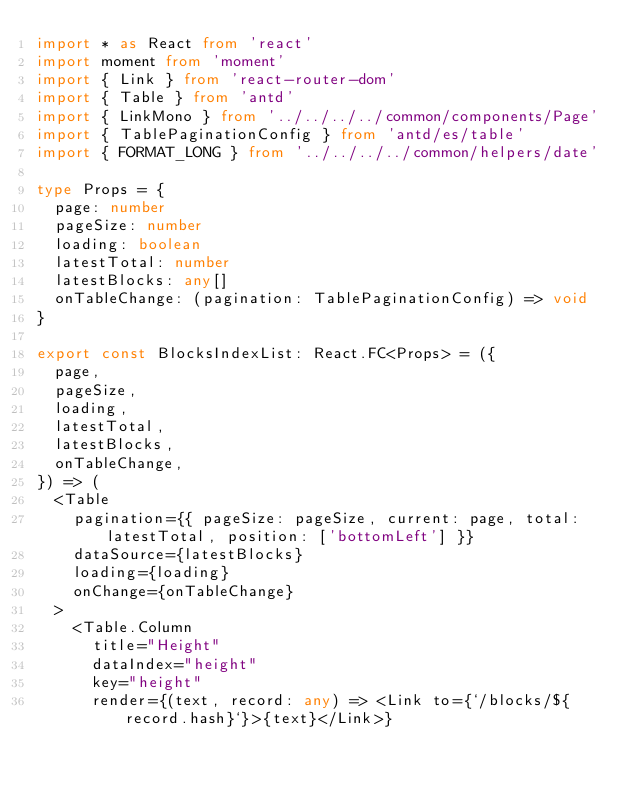<code> <loc_0><loc_0><loc_500><loc_500><_TypeScript_>import * as React from 'react'
import moment from 'moment'
import { Link } from 'react-router-dom'
import { Table } from 'antd'
import { LinkMono } from '../../../../common/components/Page'
import { TablePaginationConfig } from 'antd/es/table'
import { FORMAT_LONG } from '../../../../common/helpers/date'

type Props = {
  page: number
  pageSize: number
  loading: boolean
  latestTotal: number
  latestBlocks: any[]
  onTableChange: (pagination: TablePaginationConfig) => void
}

export const BlocksIndexList: React.FC<Props> = ({
  page,
  pageSize,
  loading,
  latestTotal,
  latestBlocks,
  onTableChange,
}) => (
  <Table
    pagination={{ pageSize: pageSize, current: page, total: latestTotal, position: ['bottomLeft'] }}
    dataSource={latestBlocks}
    loading={loading}
    onChange={onTableChange}
  >
    <Table.Column
      title="Height"
      dataIndex="height"
      key="height"
      render={(text, record: any) => <Link to={`/blocks/${record.hash}`}>{text}</Link>}</code> 